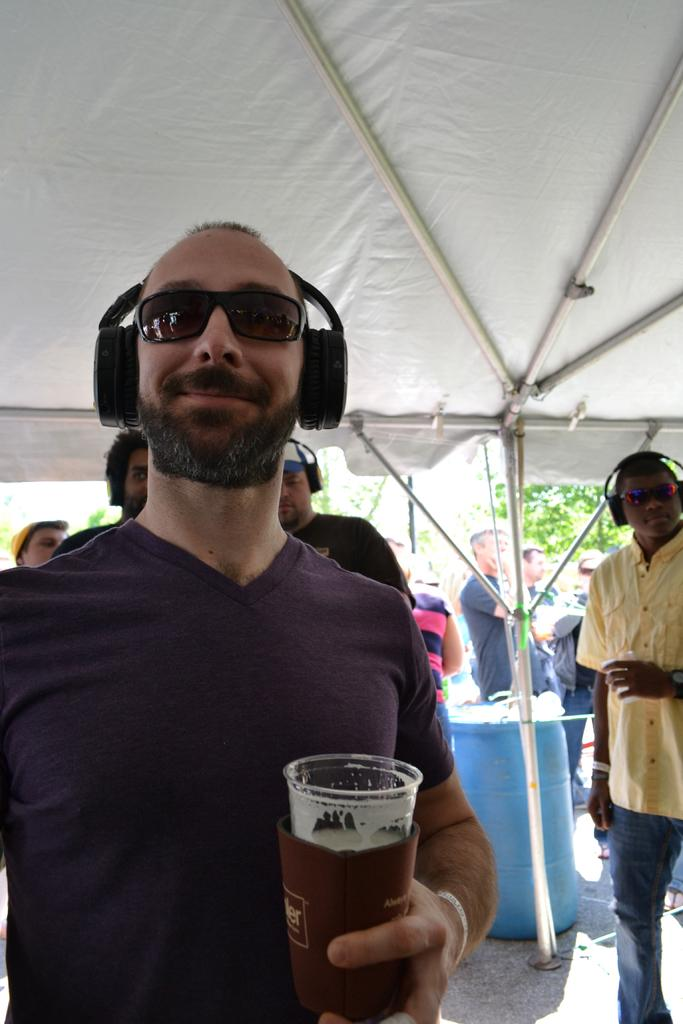What can be observed about the people in the image? There are people standing in the image. Can you describe the man in the front? The man in the front is wearing a headset and glasses, and he is holding a glass. What is present in the background of the image? There is a drum and trees in the background of the image. What type of wheel is being used by the fireman in the image? There is no fireman or wheel present in the image. How does the motion of the people in the image change throughout the scene? The image is a still photograph, so the motion of the people does not change throughout the scene. 